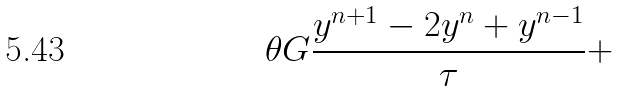Convert formula to latex. <formula><loc_0><loc_0><loc_500><loc_500>\theta G \frac { y ^ { n + 1 } - 2 y ^ { n } + y ^ { n - 1 } } { \tau } +</formula> 